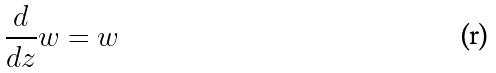Convert formula to latex. <formula><loc_0><loc_0><loc_500><loc_500>\frac { d } { d z } w = w</formula> 